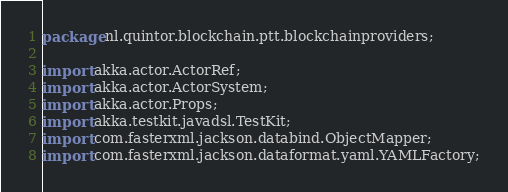<code> <loc_0><loc_0><loc_500><loc_500><_Java_>package nl.quintor.blockchain.ptt.blockchainproviders;

import akka.actor.ActorRef;
import akka.actor.ActorSystem;
import akka.actor.Props;
import akka.testkit.javadsl.TestKit;
import com.fasterxml.jackson.databind.ObjectMapper;
import com.fasterxml.jackson.dataformat.yaml.YAMLFactory;</code> 